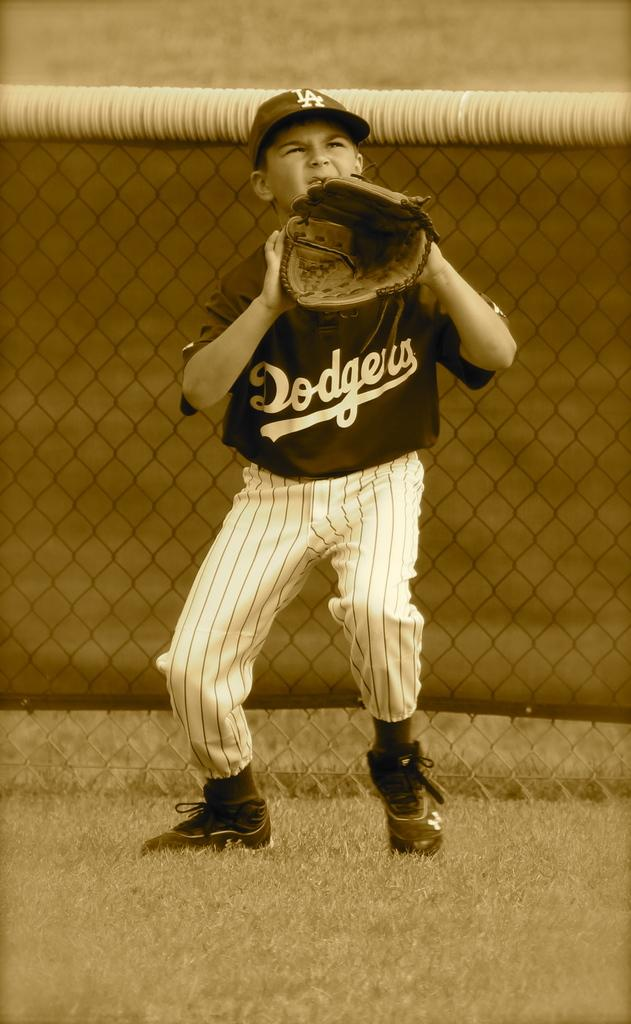<image>
Share a concise interpretation of the image provided. Older picture of a kid on the dodgers team playing baseball in the outfield. 